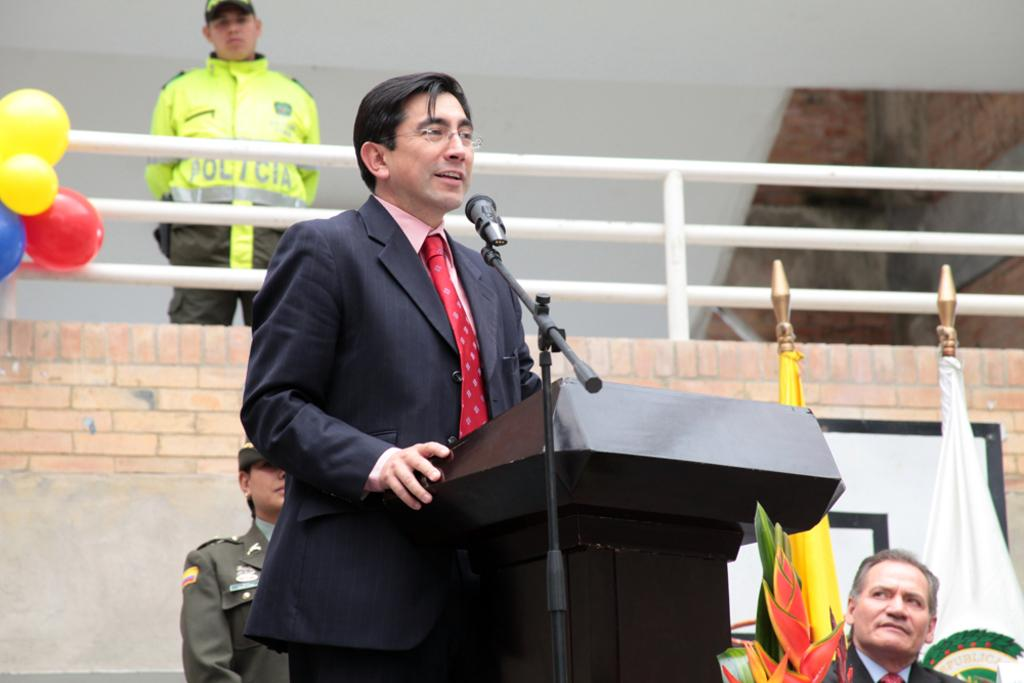What is the person in the image doing at the desk? The person is standing at a desk and holding a mic. What can be seen in the background of the image? There are flags, other persons, fencing, and a wall in the background of the image. What type of coat is the deer wearing in the image? There is no deer present in the image, and therefore no coat can be observed. How does the person's anger affect the other persons in the image? The person's anger is not mentioned in the image, so it cannot be determined how it affects the other persons. 